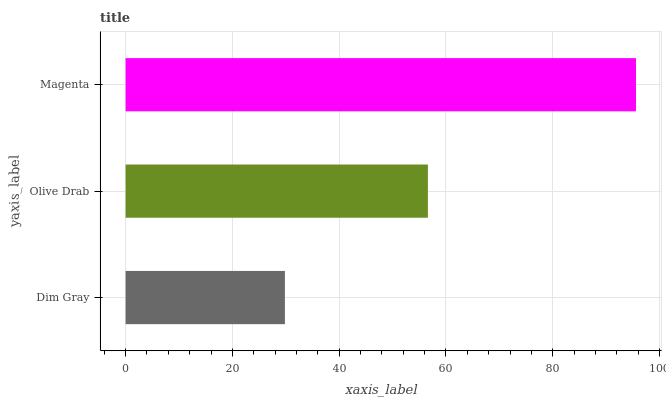Is Dim Gray the minimum?
Answer yes or no. Yes. Is Magenta the maximum?
Answer yes or no. Yes. Is Olive Drab the minimum?
Answer yes or no. No. Is Olive Drab the maximum?
Answer yes or no. No. Is Olive Drab greater than Dim Gray?
Answer yes or no. Yes. Is Dim Gray less than Olive Drab?
Answer yes or no. Yes. Is Dim Gray greater than Olive Drab?
Answer yes or no. No. Is Olive Drab less than Dim Gray?
Answer yes or no. No. Is Olive Drab the high median?
Answer yes or no. Yes. Is Olive Drab the low median?
Answer yes or no. Yes. Is Dim Gray the high median?
Answer yes or no. No. Is Magenta the low median?
Answer yes or no. No. 